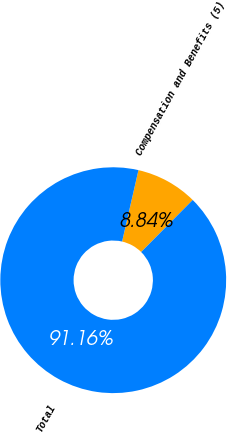Convert chart. <chart><loc_0><loc_0><loc_500><loc_500><pie_chart><fcel>Compensation and Benefits (5)<fcel>Total<nl><fcel>8.84%<fcel>91.16%<nl></chart> 